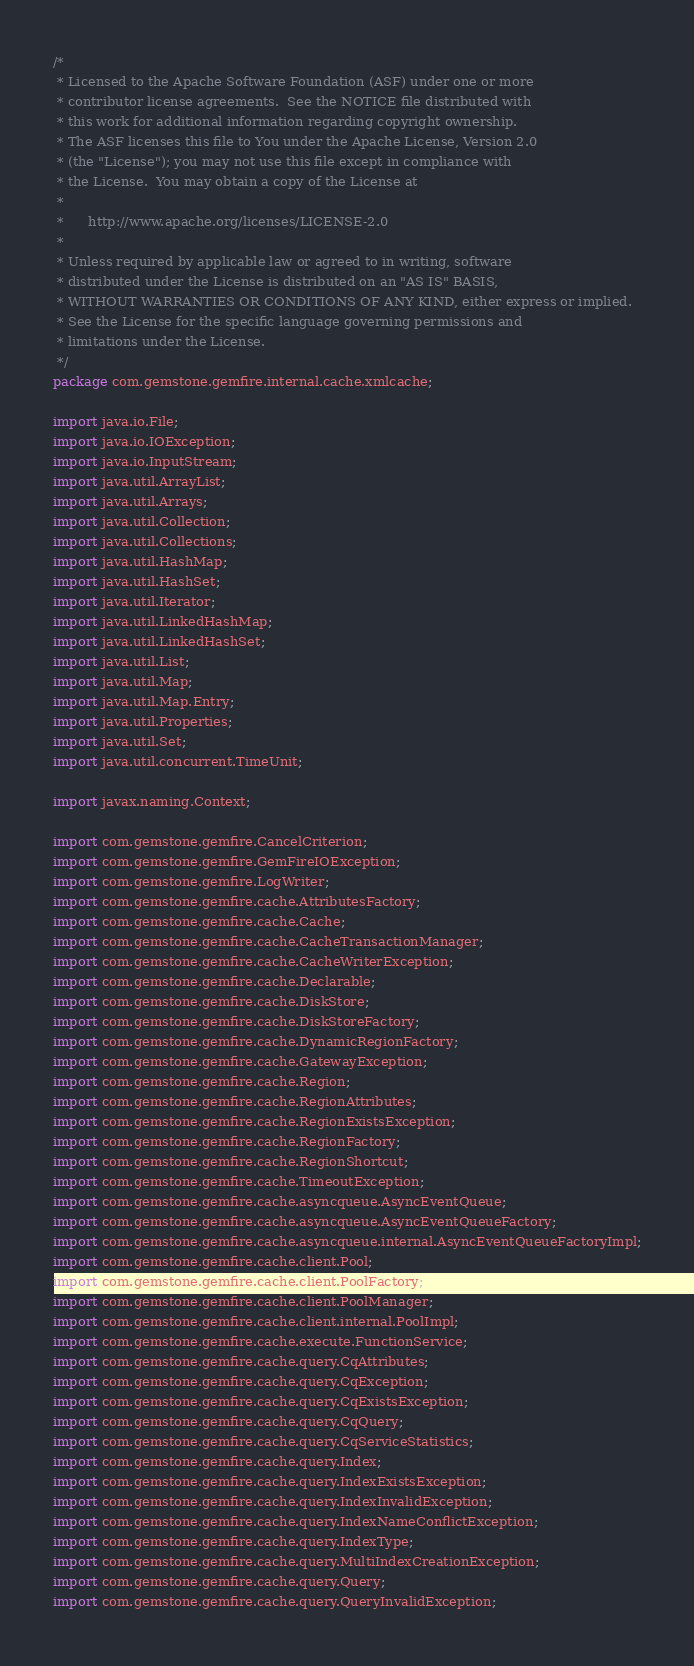<code> <loc_0><loc_0><loc_500><loc_500><_Java_>/*
 * Licensed to the Apache Software Foundation (ASF) under one or more
 * contributor license agreements.  See the NOTICE file distributed with
 * this work for additional information regarding copyright ownership.
 * The ASF licenses this file to You under the Apache License, Version 2.0
 * (the "License"); you may not use this file except in compliance with
 * the License.  You may obtain a copy of the License at
 *
 *      http://www.apache.org/licenses/LICENSE-2.0
 *
 * Unless required by applicable law or agreed to in writing, software
 * distributed under the License is distributed on an "AS IS" BASIS,
 * WITHOUT WARRANTIES OR CONDITIONS OF ANY KIND, either express or implied.
 * See the License for the specific language governing permissions and
 * limitations under the License.
 */
package com.gemstone.gemfire.internal.cache.xmlcache;

import java.io.File;
import java.io.IOException;
import java.io.InputStream;
import java.util.ArrayList;
import java.util.Arrays;
import java.util.Collection;
import java.util.Collections;
import java.util.HashMap;
import java.util.HashSet;
import java.util.Iterator;
import java.util.LinkedHashMap;
import java.util.LinkedHashSet;
import java.util.List;
import java.util.Map;
import java.util.Map.Entry;
import java.util.Properties;
import java.util.Set;
import java.util.concurrent.TimeUnit;

import javax.naming.Context;

import com.gemstone.gemfire.CancelCriterion;
import com.gemstone.gemfire.GemFireIOException;
import com.gemstone.gemfire.LogWriter;
import com.gemstone.gemfire.cache.AttributesFactory;
import com.gemstone.gemfire.cache.Cache;
import com.gemstone.gemfire.cache.CacheTransactionManager;
import com.gemstone.gemfire.cache.CacheWriterException;
import com.gemstone.gemfire.cache.Declarable;
import com.gemstone.gemfire.cache.DiskStore;
import com.gemstone.gemfire.cache.DiskStoreFactory;
import com.gemstone.gemfire.cache.DynamicRegionFactory;
import com.gemstone.gemfire.cache.GatewayException;
import com.gemstone.gemfire.cache.Region;
import com.gemstone.gemfire.cache.RegionAttributes;
import com.gemstone.gemfire.cache.RegionExistsException;
import com.gemstone.gemfire.cache.RegionFactory;
import com.gemstone.gemfire.cache.RegionShortcut;
import com.gemstone.gemfire.cache.TimeoutException;
import com.gemstone.gemfire.cache.asyncqueue.AsyncEventQueue;
import com.gemstone.gemfire.cache.asyncqueue.AsyncEventQueueFactory;
import com.gemstone.gemfire.cache.asyncqueue.internal.AsyncEventQueueFactoryImpl;
import com.gemstone.gemfire.cache.client.Pool;
import com.gemstone.gemfire.cache.client.PoolFactory;
import com.gemstone.gemfire.cache.client.PoolManager;
import com.gemstone.gemfire.cache.client.internal.PoolImpl;
import com.gemstone.gemfire.cache.execute.FunctionService;
import com.gemstone.gemfire.cache.query.CqAttributes;
import com.gemstone.gemfire.cache.query.CqException;
import com.gemstone.gemfire.cache.query.CqExistsException;
import com.gemstone.gemfire.cache.query.CqQuery;
import com.gemstone.gemfire.cache.query.CqServiceStatistics;
import com.gemstone.gemfire.cache.query.Index;
import com.gemstone.gemfire.cache.query.IndexExistsException;
import com.gemstone.gemfire.cache.query.IndexInvalidException;
import com.gemstone.gemfire.cache.query.IndexNameConflictException;
import com.gemstone.gemfire.cache.query.IndexType;
import com.gemstone.gemfire.cache.query.MultiIndexCreationException;
import com.gemstone.gemfire.cache.query.Query;
import com.gemstone.gemfire.cache.query.QueryInvalidException;</code> 